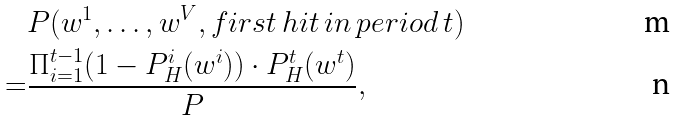<formula> <loc_0><loc_0><loc_500><loc_500>& P ( w ^ { 1 } , \dots , w ^ { V } , f i r s t \, h i t \, i n \, p e r i o d \, t ) \\ = & \frac { \Pi _ { i = 1 } ^ { t - 1 } ( 1 - P _ { H } ^ { i } ( w ^ { i } ) ) \cdot P _ { H } ^ { t } ( w ^ { t } ) } { P } ,</formula> 